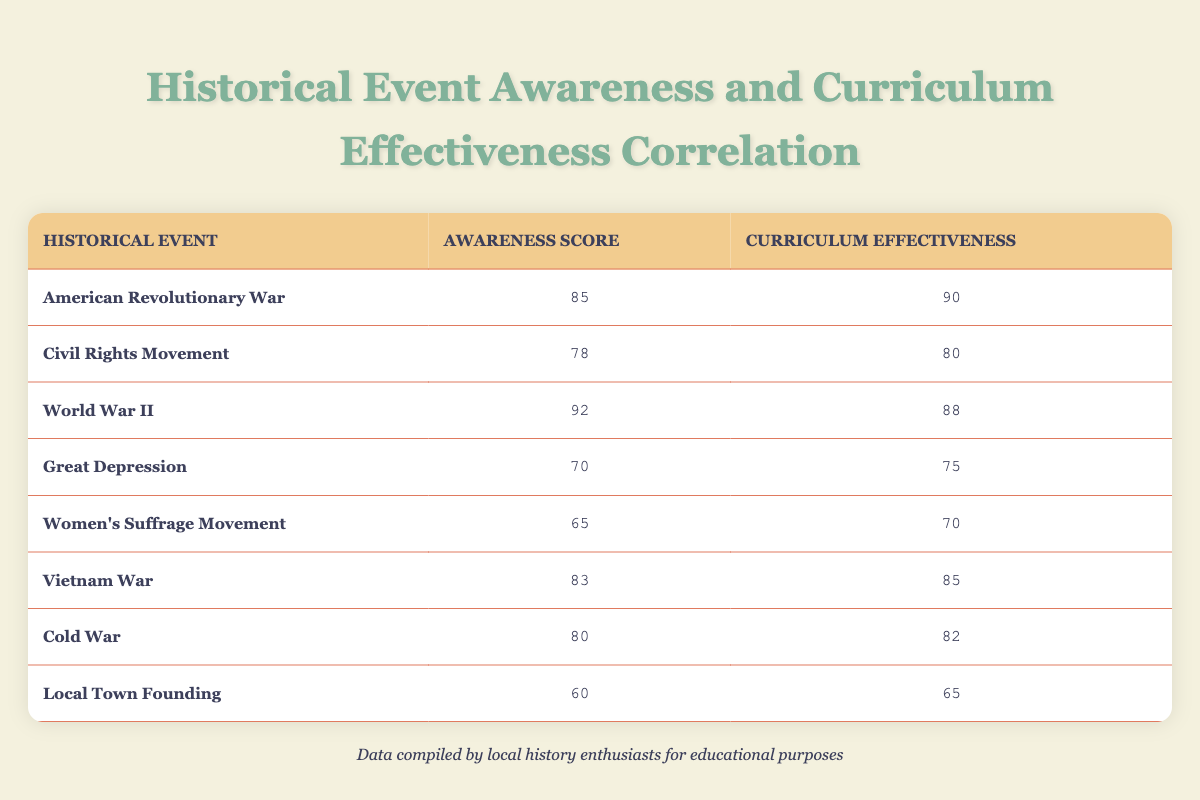What is the awareness score for the World War II event? According to the table, the awareness score for the World War II event is listed directly. It shows a value of 92.
Answer: 92 Which historical event has the lowest curriculum effectiveness score? Looking through the curriculum effectiveness scores, the Local Town Founding event has the lowest score, which is 65.
Answer: Local Town Founding Is the awareness score for the Women's Suffrage Movement greater than 70? The awareness score for the Women's Suffrage Movement is listed as 65, which is less than 70. Therefore, the statement is false.
Answer: No What is the difference between the awareness score of the Civil Rights Movement and the Great Depression? The awareness score for the Civil Rights Movement is 78, and for the Great Depression, it is 70. The difference can be calculated as 78 - 70 = 8.
Answer: 8 What is the average curriculum effectiveness score across all events listed? To find the average, add together all the curriculum effectiveness scores: 90 + 80 + 88 + 75 + 70 + 85 + 82 + 65 = 730. Then, divide by the number of events (8): 730 ÷ 8 = 91.25.
Answer: 91.25 Is the awareness score for the Cold War equal to the curriculum effectiveness score for the Vietnam War? The awareness score for the Cold War is 80, while the curriculum effectiveness score for the Vietnam War is 85. Since they are not equal, the statement is false.
Answer: No Which event has the highest combined total of awareness score and curriculum effectiveness? The combined total for each event can be calculated. The highest combined score is for the World War II event: 92 (awareness) + 88 (effectiveness) = 180.
Answer: World War II How many historical events have an awareness score above 80? From the table, the events with awareness scores above 80 are: American Revolutionary War (85), World War II (92), Vietnam War (83), and Cold War (80). This makes for a total of 4 events.
Answer: 4 